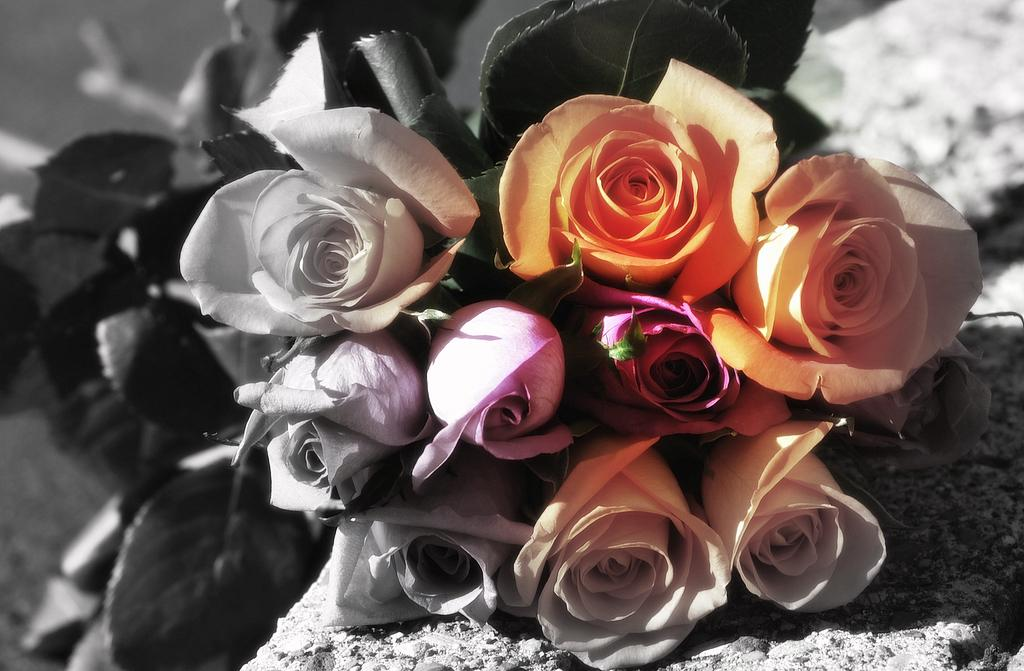What is the main subject of the image? The main subject of the image is a bunch of flowers. Can you describe the flowers in the image? The image is a zoomed-in picture of the flowers, so it focuses on the details of the flowers themselves. What type of roof can be seen above the stage in the image? There is no stage or roof present in the image; it is a zoomed-in picture of a bunch of flowers. 